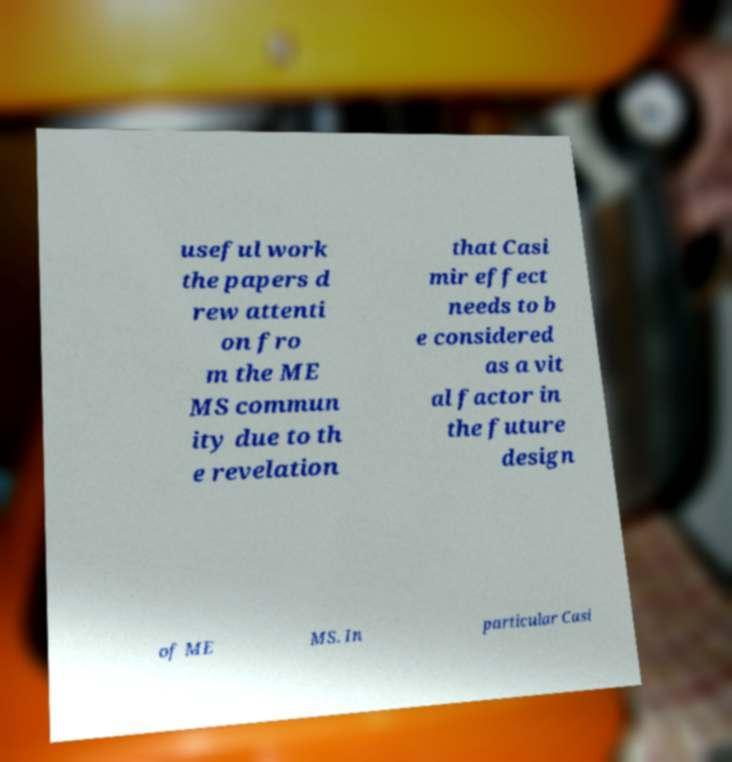For documentation purposes, I need the text within this image transcribed. Could you provide that? useful work the papers d rew attenti on fro m the ME MS commun ity due to th e revelation that Casi mir effect needs to b e considered as a vit al factor in the future design of ME MS. In particular Casi 